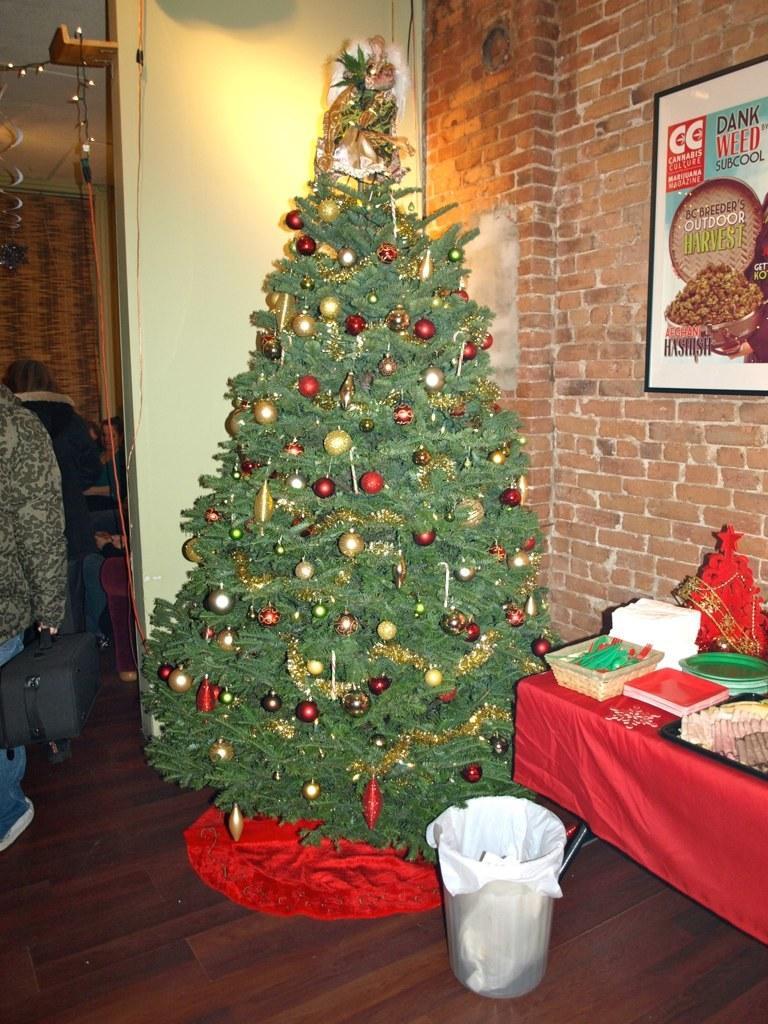Please provide a concise description of this image. In this image I can see a Christmas tree and on it I can see decorations. I can also see a dustbin, few plates, red colour cloth and over here I can see few other stuffs. In the background I can see two persons are standing, few lights and here I can see a board on this wall. I can also see something is written over here. 